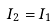Convert formula to latex. <formula><loc_0><loc_0><loc_500><loc_500>I _ { 2 } = I _ { 1 }</formula> 